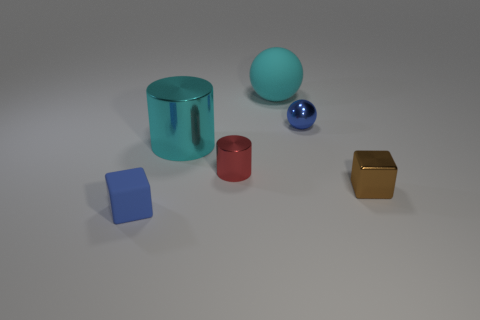Add 1 small red objects. How many objects exist? 7 Subtract all balls. How many objects are left? 4 Subtract all blue blocks. How many yellow spheres are left? 0 Subtract all big red matte objects. Subtract all big cyan cylinders. How many objects are left? 5 Add 5 cyan matte things. How many cyan matte things are left? 6 Add 3 small yellow metal objects. How many small yellow metal objects exist? 3 Subtract 0 red blocks. How many objects are left? 6 Subtract 2 cubes. How many cubes are left? 0 Subtract all red cubes. Subtract all red balls. How many cubes are left? 2 